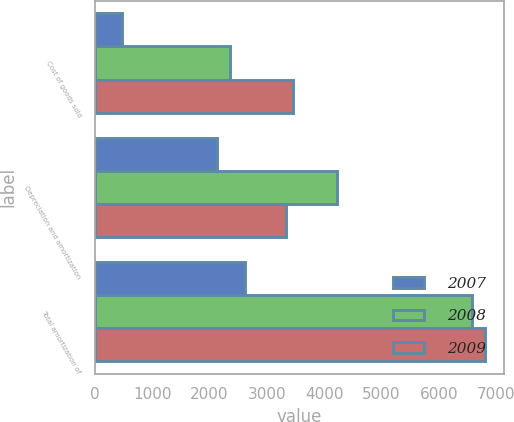Convert chart. <chart><loc_0><loc_0><loc_500><loc_500><stacked_bar_chart><ecel><fcel>Cost of goods sold<fcel>Depreciation and amortization<fcel>Total amortization of<nl><fcel>2007<fcel>478<fcel>2136<fcel>2614<nl><fcel>2008<fcel>2350<fcel>4229<fcel>6579<nl><fcel>2009<fcel>3462<fcel>3334<fcel>6796<nl></chart> 